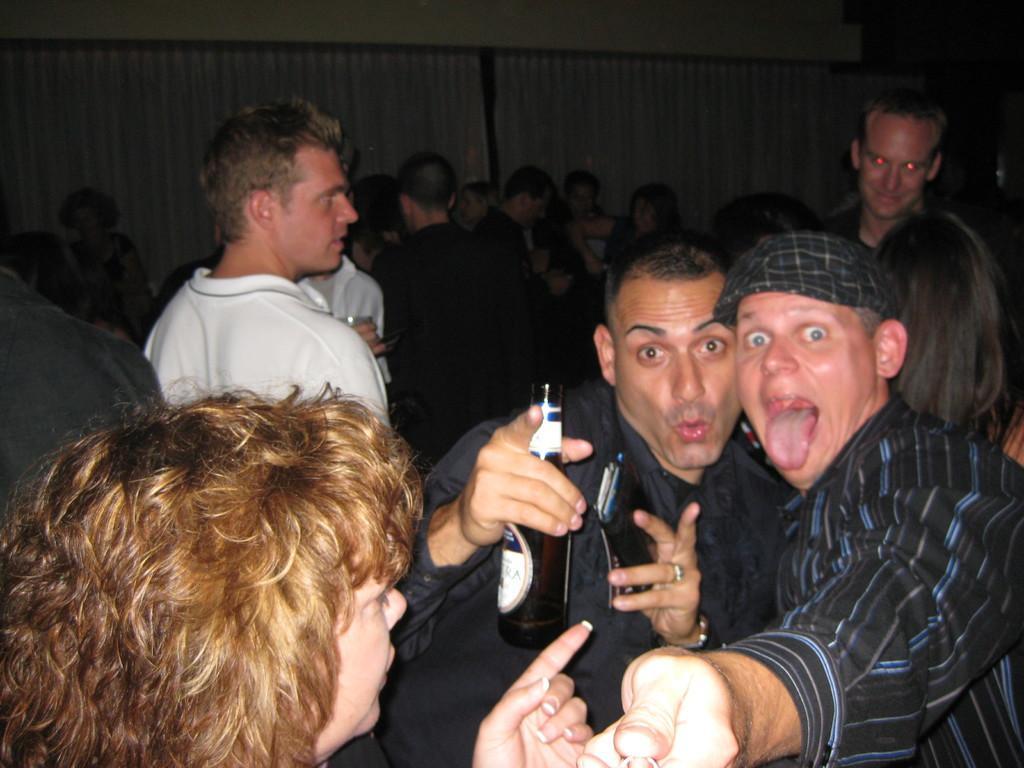Please provide a concise description of this image. On the right there is a man who is wearing cap and t-shirt. He is standing near to the man who is holding mobile phone and wine bottle. At the bottom left there is a woman. In the background we can see the group of persons standing near to the cloth. On the top right there is a cover near to the wall. 